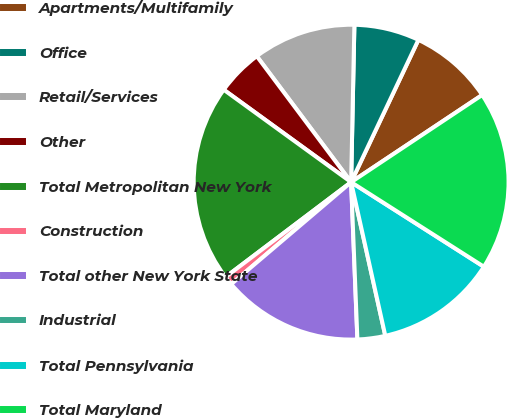Convert chart to OTSL. <chart><loc_0><loc_0><loc_500><loc_500><pie_chart><fcel>Apartments/Multifamily<fcel>Office<fcel>Retail/Services<fcel>Other<fcel>Total Metropolitan New York<fcel>Construction<fcel>Total other New York State<fcel>Industrial<fcel>Total Pennsylvania<fcel>Total Maryland<nl><fcel>8.63%<fcel>6.7%<fcel>10.56%<fcel>4.78%<fcel>20.29%<fcel>0.92%<fcel>14.42%<fcel>2.85%<fcel>12.49%<fcel>18.37%<nl></chart> 